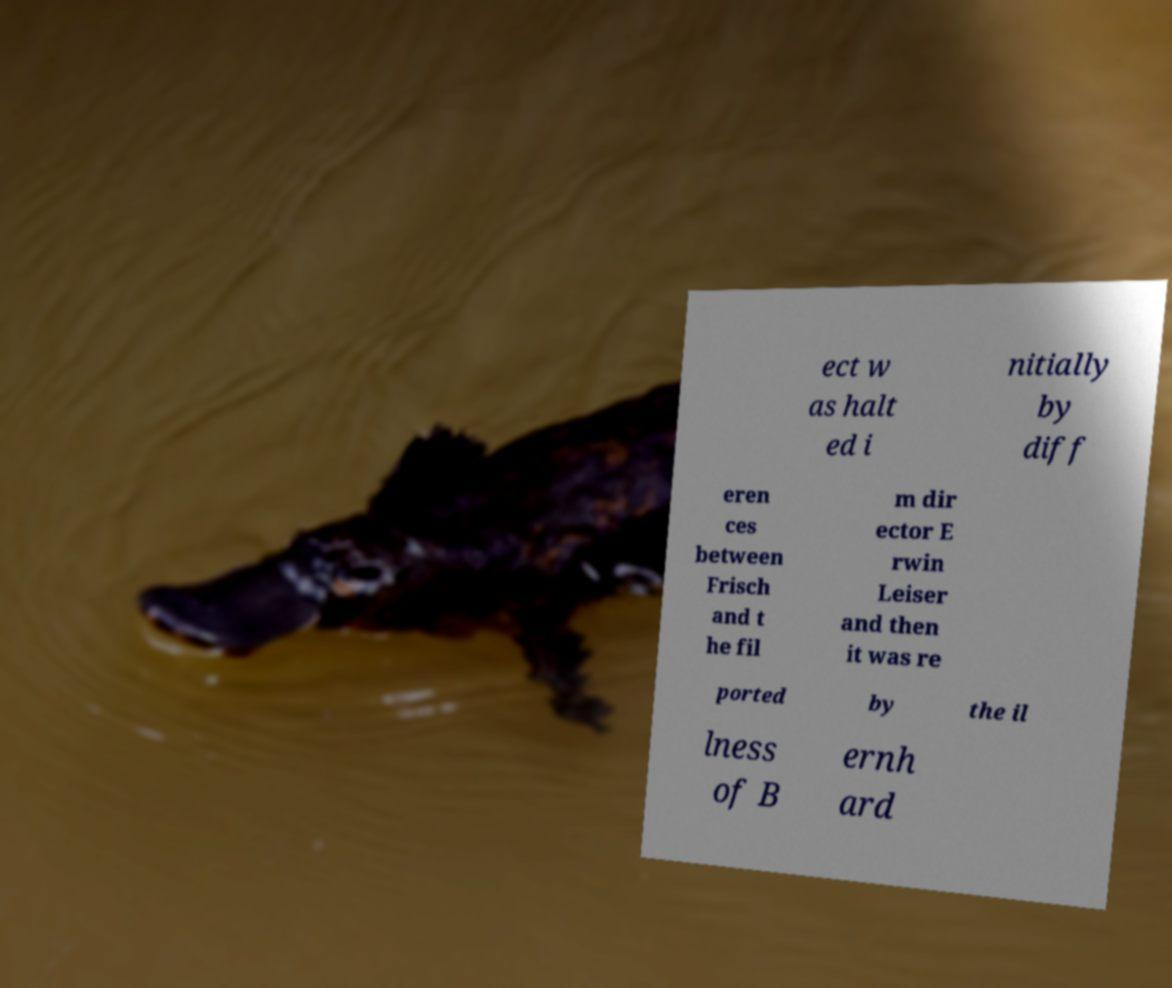Can you accurately transcribe the text from the provided image for me? ect w as halt ed i nitially by diff eren ces between Frisch and t he fil m dir ector E rwin Leiser and then it was re ported by the il lness of B ernh ard 